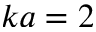Convert formula to latex. <formula><loc_0><loc_0><loc_500><loc_500>k a = 2</formula> 